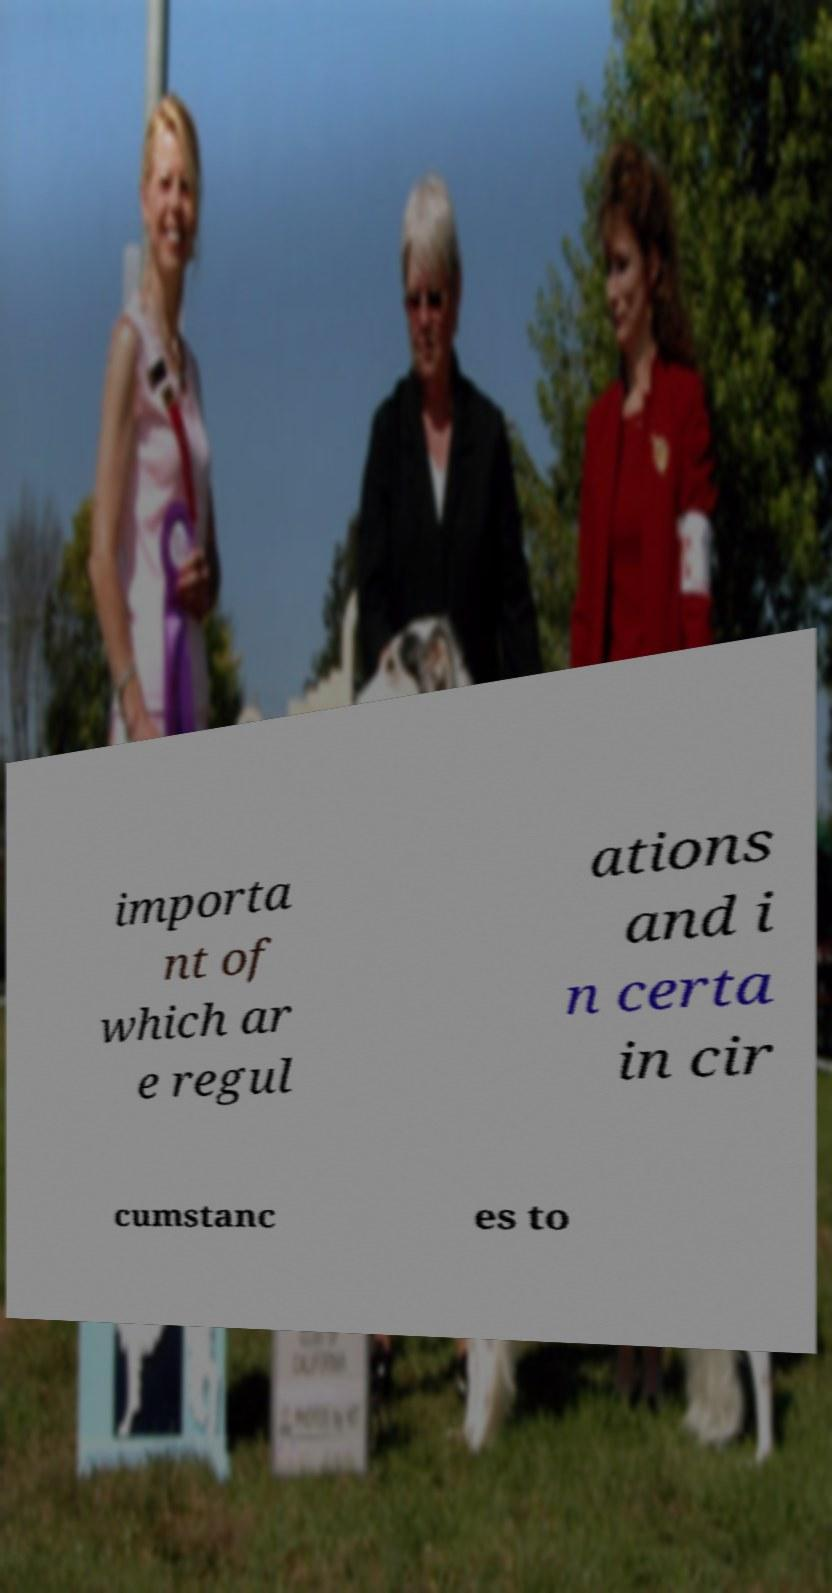Please identify and transcribe the text found in this image. importa nt of which ar e regul ations and i n certa in cir cumstanc es to 